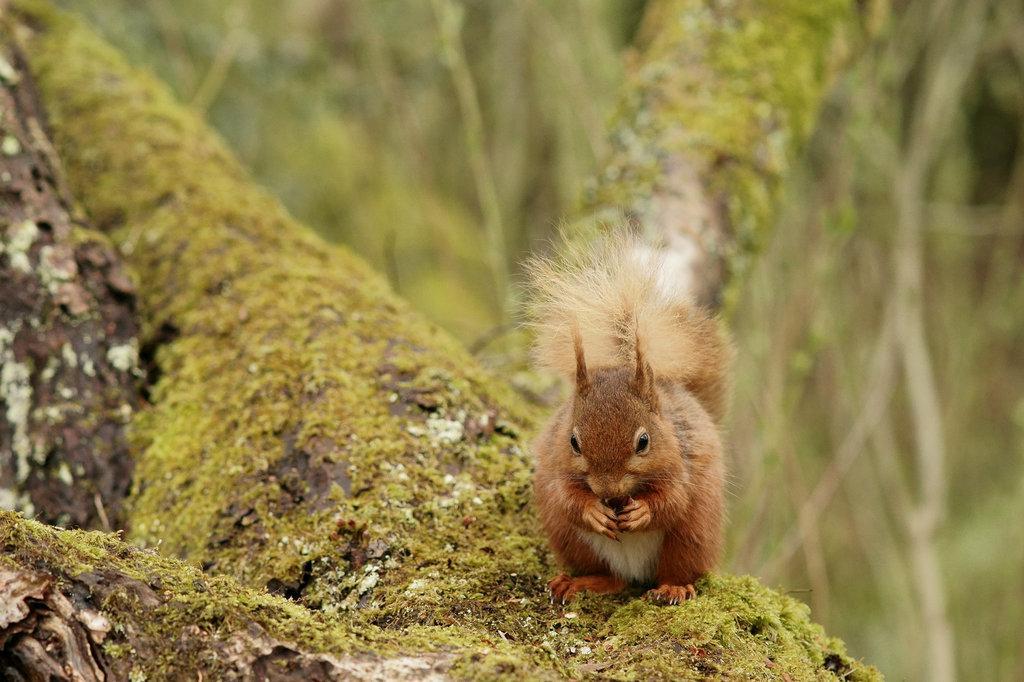Can you describe this image briefly? In this image we can see a squirrel on the branch of a tree. 